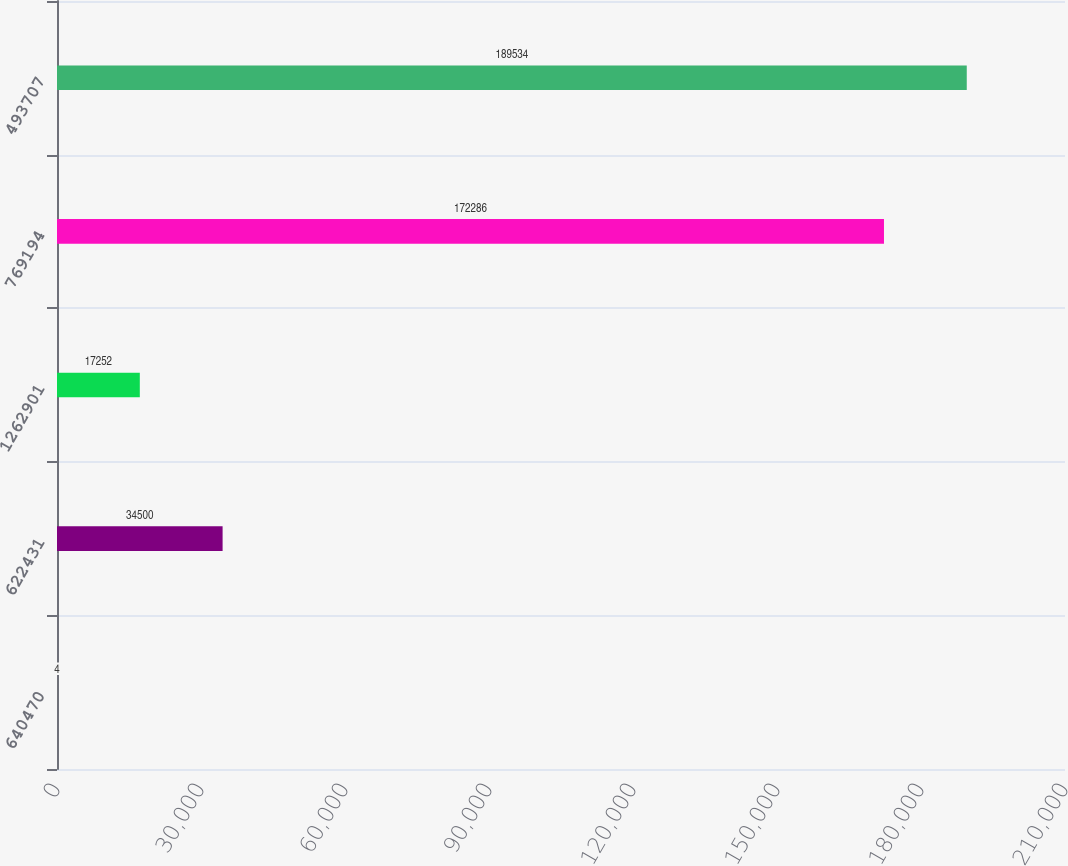Convert chart to OTSL. <chart><loc_0><loc_0><loc_500><loc_500><bar_chart><fcel>640470<fcel>622431<fcel>1262901<fcel>769194<fcel>493707<nl><fcel>4<fcel>34500<fcel>17252<fcel>172286<fcel>189534<nl></chart> 